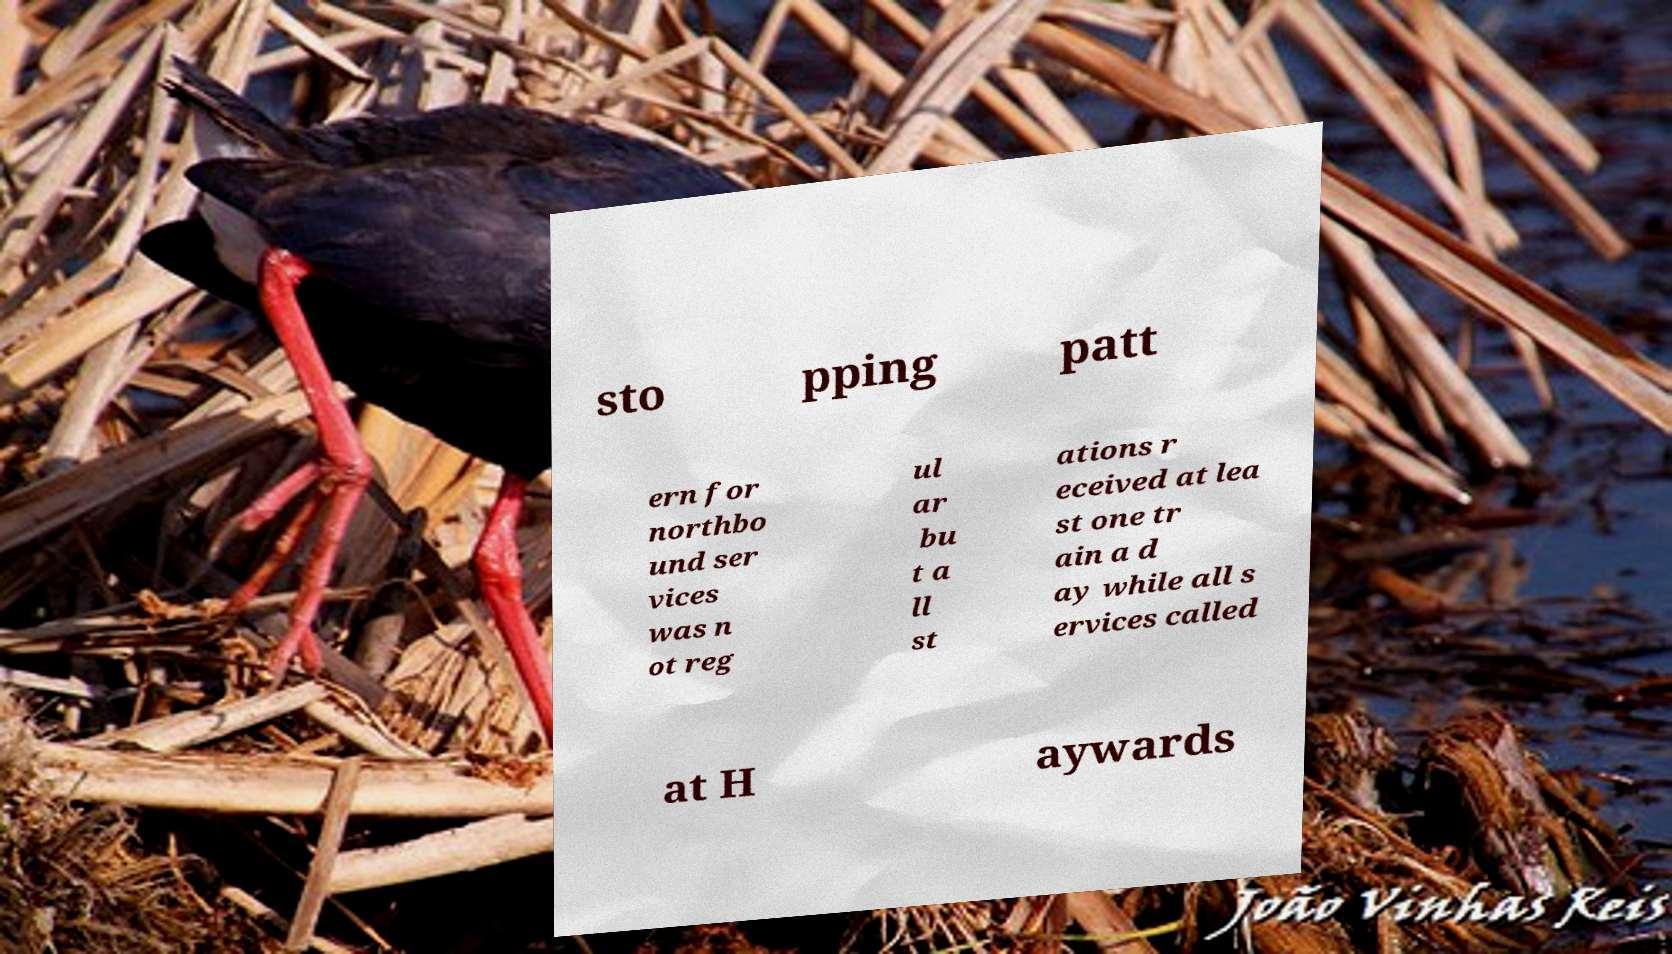Please identify and transcribe the text found in this image. sto pping patt ern for northbo und ser vices was n ot reg ul ar bu t a ll st ations r eceived at lea st one tr ain a d ay while all s ervices called at H aywards 